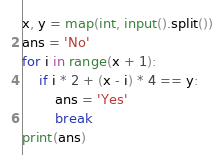Convert code to text. <code><loc_0><loc_0><loc_500><loc_500><_Python_>x, y = map(int, input().split())
ans = 'No'
for i in range(x + 1):
    if i * 2 + (x - i) * 4 == y:
        ans = 'Yes'
        break
print(ans)</code> 